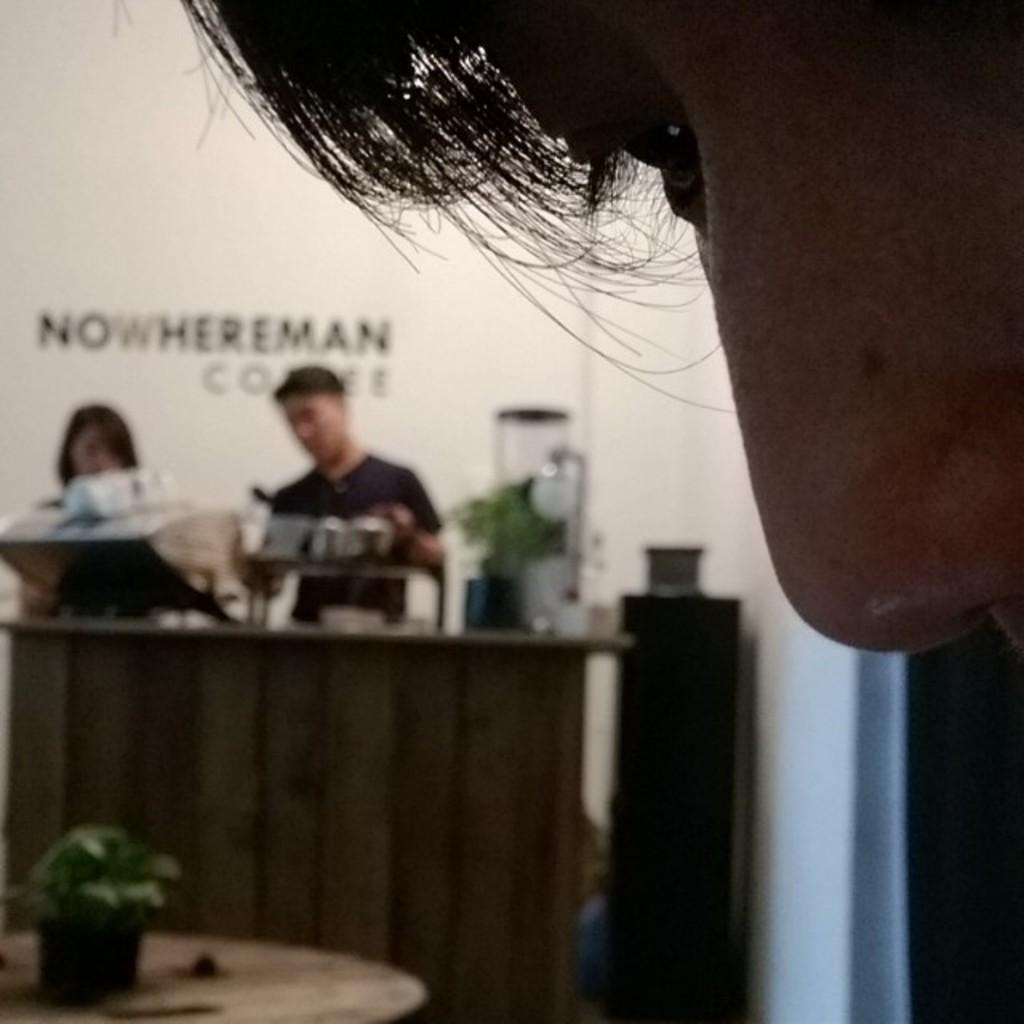What body parts are visible in the close-up in the image? The image contains a close-up of a human eye, nose, and hair. What can be seen in the background of the image? There are two people standing near a table and a plant in the background. What type of ink is being used by the person wearing a vest in the image? There is no person wearing a vest or using ink present in the image. What type of dinner is being served on the table in the image? There is no dinner or table visible in the image; it only shows a close-up of a human eye, nose, and hair, with two people and a plant in the background. 